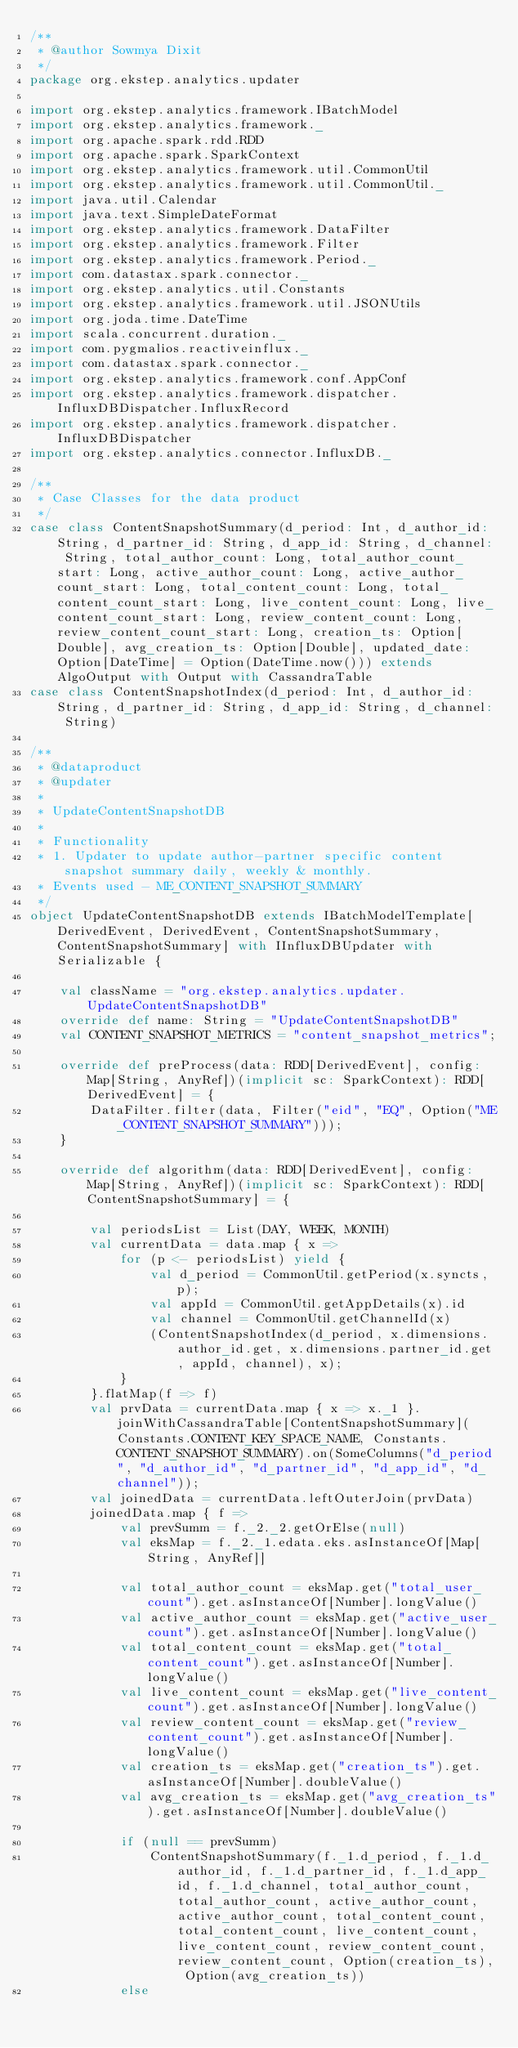<code> <loc_0><loc_0><loc_500><loc_500><_Scala_>/**
 * @author Sowmya Dixit
 */
package org.ekstep.analytics.updater

import org.ekstep.analytics.framework.IBatchModel
import org.ekstep.analytics.framework._
import org.apache.spark.rdd.RDD
import org.apache.spark.SparkContext
import org.ekstep.analytics.framework.util.CommonUtil
import org.ekstep.analytics.framework.util.CommonUtil._
import java.util.Calendar
import java.text.SimpleDateFormat
import org.ekstep.analytics.framework.DataFilter
import org.ekstep.analytics.framework.Filter
import org.ekstep.analytics.framework.Period._
import com.datastax.spark.connector._
import org.ekstep.analytics.util.Constants
import org.ekstep.analytics.framework.util.JSONUtils
import org.joda.time.DateTime
import scala.concurrent.duration._
import com.pygmalios.reactiveinflux._
import com.datastax.spark.connector._
import org.ekstep.analytics.framework.conf.AppConf
import org.ekstep.analytics.framework.dispatcher.InfluxDBDispatcher.InfluxRecord
import org.ekstep.analytics.framework.dispatcher.InfluxDBDispatcher
import org.ekstep.analytics.connector.InfluxDB._

/**
 * Case Classes for the data product
 */
case class ContentSnapshotSummary(d_period: Int, d_author_id: String, d_partner_id: String, d_app_id: String, d_channel: String, total_author_count: Long, total_author_count_start: Long, active_author_count: Long, active_author_count_start: Long, total_content_count: Long, total_content_count_start: Long, live_content_count: Long, live_content_count_start: Long, review_content_count: Long, review_content_count_start: Long, creation_ts: Option[Double], avg_creation_ts: Option[Double], updated_date: Option[DateTime] = Option(DateTime.now())) extends AlgoOutput with Output with CassandraTable
case class ContentSnapshotIndex(d_period: Int, d_author_id: String, d_partner_id: String, d_app_id: String, d_channel: String)

/**
 * @dataproduct
 * @updater
 *
 * UpdateContentSnapshotDB
 *
 * Functionality
 * 1. Updater to update author-partner specific content snapshot summary daily, weekly & monthly.
 * Events used - ME_CONTENT_SNAPSHOT_SUMMARY
 */
object UpdateContentSnapshotDB extends IBatchModelTemplate[DerivedEvent, DerivedEvent, ContentSnapshotSummary, ContentSnapshotSummary] with IInfluxDBUpdater with Serializable {

    val className = "org.ekstep.analytics.updater.UpdateContentSnapshotDB"
    override def name: String = "UpdateContentSnapshotDB"
    val CONTENT_SNAPSHOT_METRICS = "content_snapshot_metrics";

    override def preProcess(data: RDD[DerivedEvent], config: Map[String, AnyRef])(implicit sc: SparkContext): RDD[DerivedEvent] = {
        DataFilter.filter(data, Filter("eid", "EQ", Option("ME_CONTENT_SNAPSHOT_SUMMARY")));
    }

    override def algorithm(data: RDD[DerivedEvent], config: Map[String, AnyRef])(implicit sc: SparkContext): RDD[ContentSnapshotSummary] = {

        val periodsList = List(DAY, WEEK, MONTH)
        val currentData = data.map { x =>
            for (p <- periodsList) yield {
                val d_period = CommonUtil.getPeriod(x.syncts, p);
                val appId = CommonUtil.getAppDetails(x).id
                val channel = CommonUtil.getChannelId(x)
                (ContentSnapshotIndex(d_period, x.dimensions.author_id.get, x.dimensions.partner_id.get, appId, channel), x);
            }
        }.flatMap(f => f)
        val prvData = currentData.map { x => x._1 }.joinWithCassandraTable[ContentSnapshotSummary](Constants.CONTENT_KEY_SPACE_NAME, Constants.CONTENT_SNAPSHOT_SUMMARY).on(SomeColumns("d_period", "d_author_id", "d_partner_id", "d_app_id", "d_channel"));
        val joinedData = currentData.leftOuterJoin(prvData)
        joinedData.map { f =>
            val prevSumm = f._2._2.getOrElse(null)
            val eksMap = f._2._1.edata.eks.asInstanceOf[Map[String, AnyRef]]

            val total_author_count = eksMap.get("total_user_count").get.asInstanceOf[Number].longValue()
            val active_author_count = eksMap.get("active_user_count").get.asInstanceOf[Number].longValue()
            val total_content_count = eksMap.get("total_content_count").get.asInstanceOf[Number].longValue()
            val live_content_count = eksMap.get("live_content_count").get.asInstanceOf[Number].longValue()
            val review_content_count = eksMap.get("review_content_count").get.asInstanceOf[Number].longValue()
            val creation_ts = eksMap.get("creation_ts").get.asInstanceOf[Number].doubleValue()
            val avg_creation_ts = eksMap.get("avg_creation_ts").get.asInstanceOf[Number].doubleValue()

            if (null == prevSumm)
                ContentSnapshotSummary(f._1.d_period, f._1.d_author_id, f._1.d_partner_id, f._1.d_app_id, f._1.d_channel, total_author_count, total_author_count, active_author_count, active_author_count, total_content_count, total_content_count, live_content_count, live_content_count, review_content_count, review_content_count, Option(creation_ts), Option(avg_creation_ts))
            else</code> 